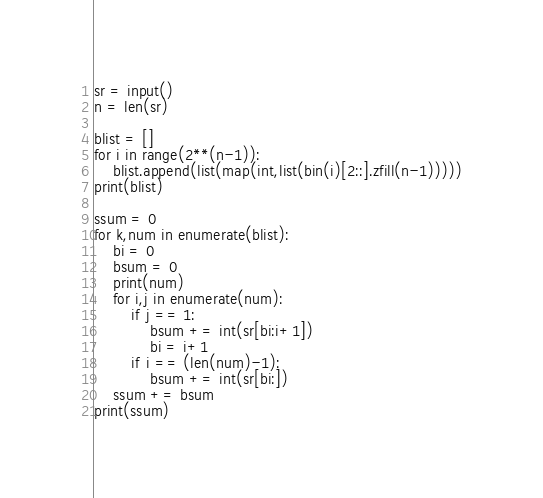Convert code to text. <code><loc_0><loc_0><loc_500><loc_500><_Python_>sr = input()
n = len(sr)

blist = []
for i in range(2**(n-1)):
    blist.append(list(map(int,list(bin(i)[2::].zfill(n-1)))))
print(blist)

ssum = 0
for k,num in enumerate(blist):
    bi = 0
    bsum = 0
    print(num)
    for i,j in enumerate(num):
        if j == 1:
            bsum += int(sr[bi:i+1])
            bi = i+1
        if i == (len(num)-1):
            bsum += int(sr[bi:])
    ssum += bsum
print(ssum)</code> 